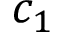Convert formula to latex. <formula><loc_0><loc_0><loc_500><loc_500>c _ { 1 }</formula> 